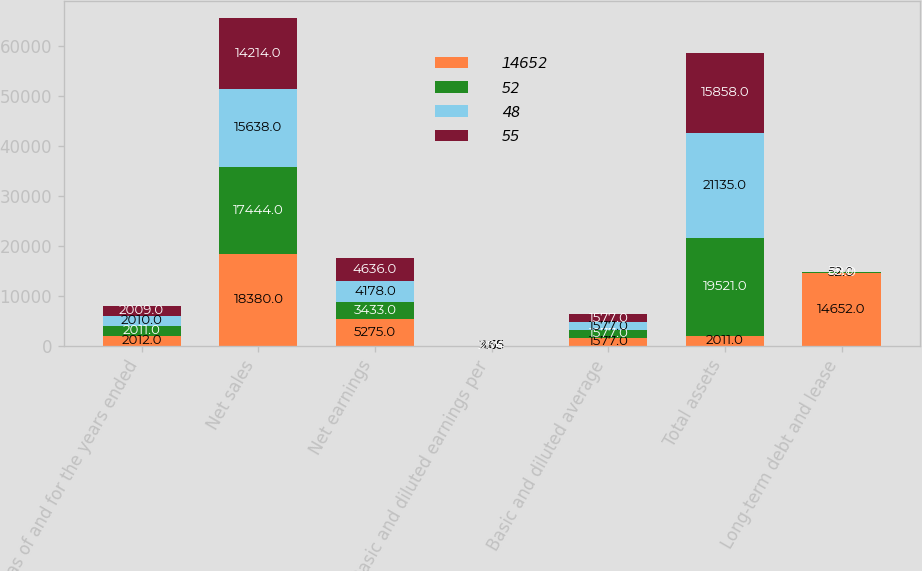Convert chart. <chart><loc_0><loc_0><loc_500><loc_500><stacked_bar_chart><ecel><fcel>as of and for the years ended<fcel>Net sales<fcel>Net earnings<fcel>Basic and diluted earnings per<fcel>Basic and diluted average<fcel>Total assets<fcel>Long-term debt and lease<nl><fcel>14652<fcel>2012<fcel>18380<fcel>5275<fcel>3.35<fcel>1577<fcel>2011<fcel>14652<nl><fcel>52<fcel>2011<fcel>17444<fcel>3433<fcel>2.18<fcel>1577<fcel>19521<fcel>48<nl><fcel>48<fcel>2010<fcel>15638<fcel>4178<fcel>2.65<fcel>1577<fcel>21135<fcel>52<nl><fcel>55<fcel>2009<fcel>14214<fcel>4636<fcel>2.94<fcel>1577<fcel>15858<fcel>55<nl></chart> 